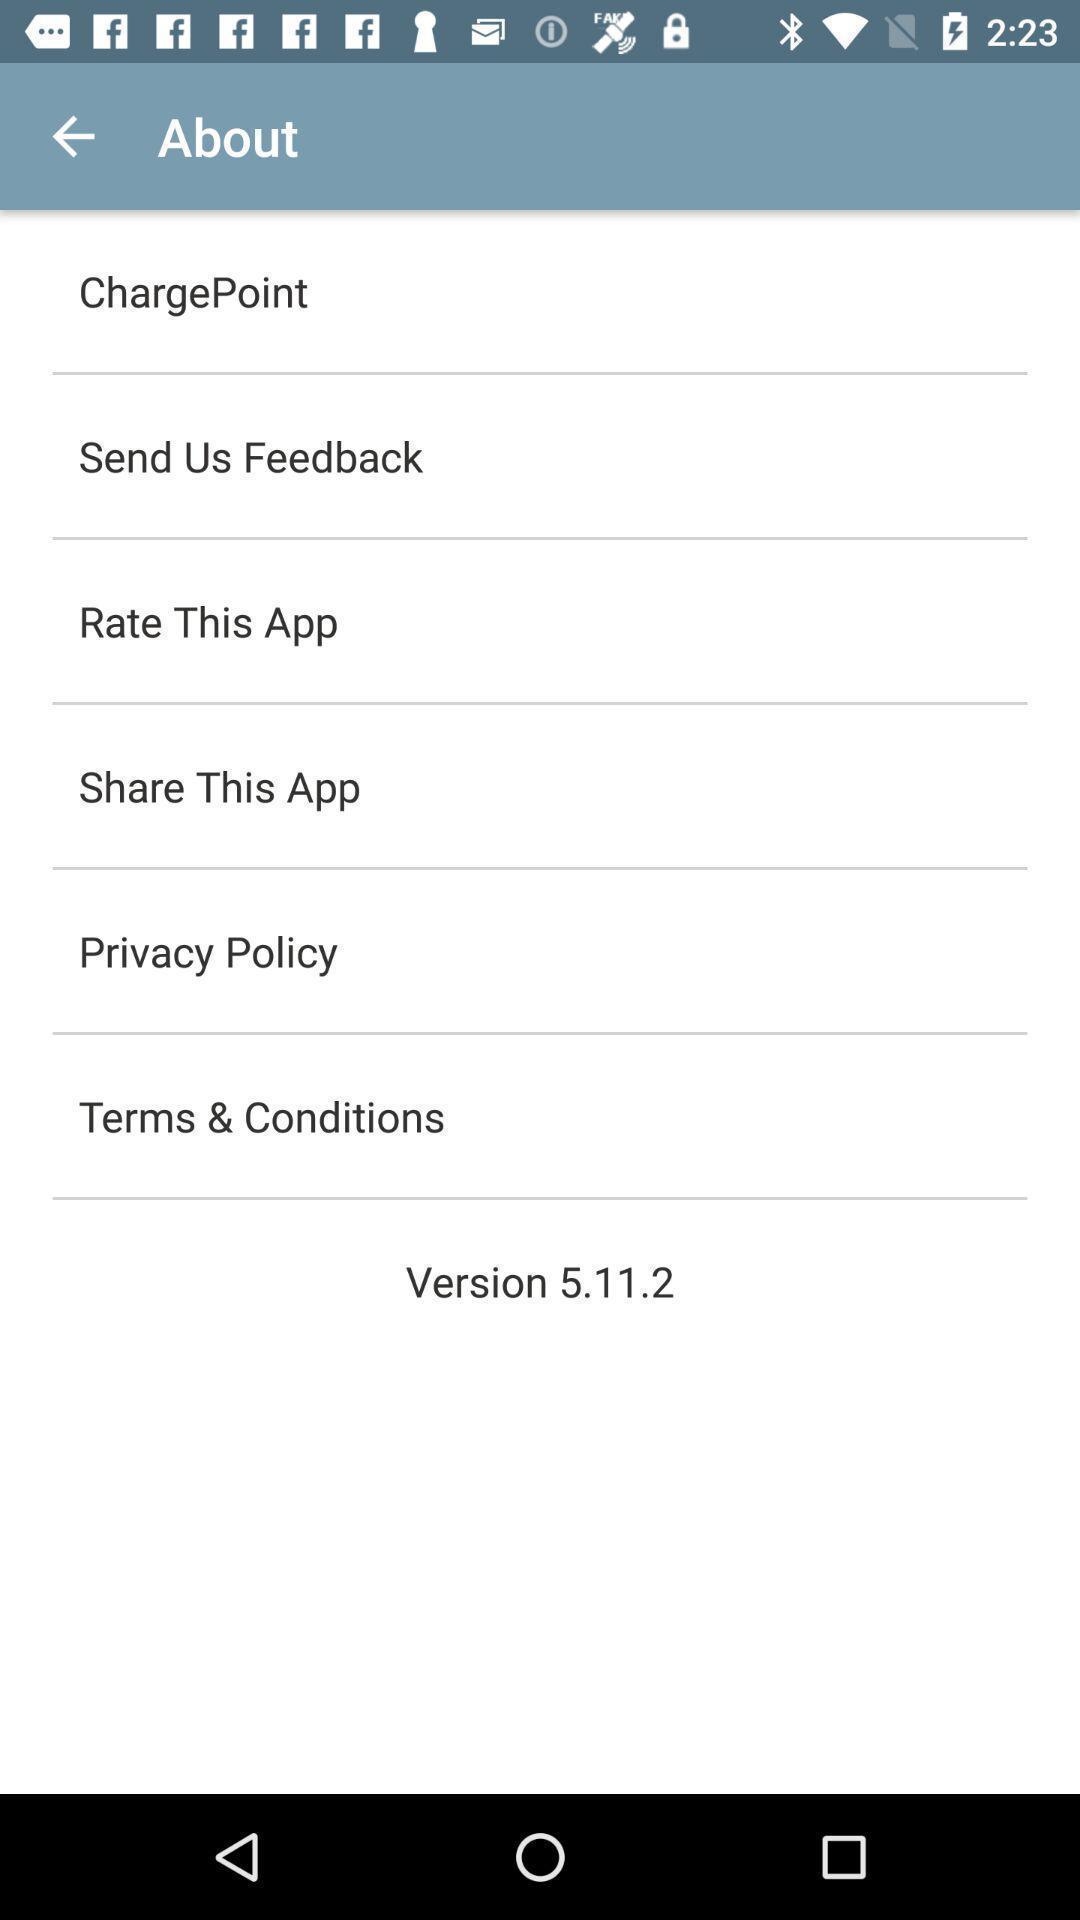What details can you identify in this image? Screen shows about details. 